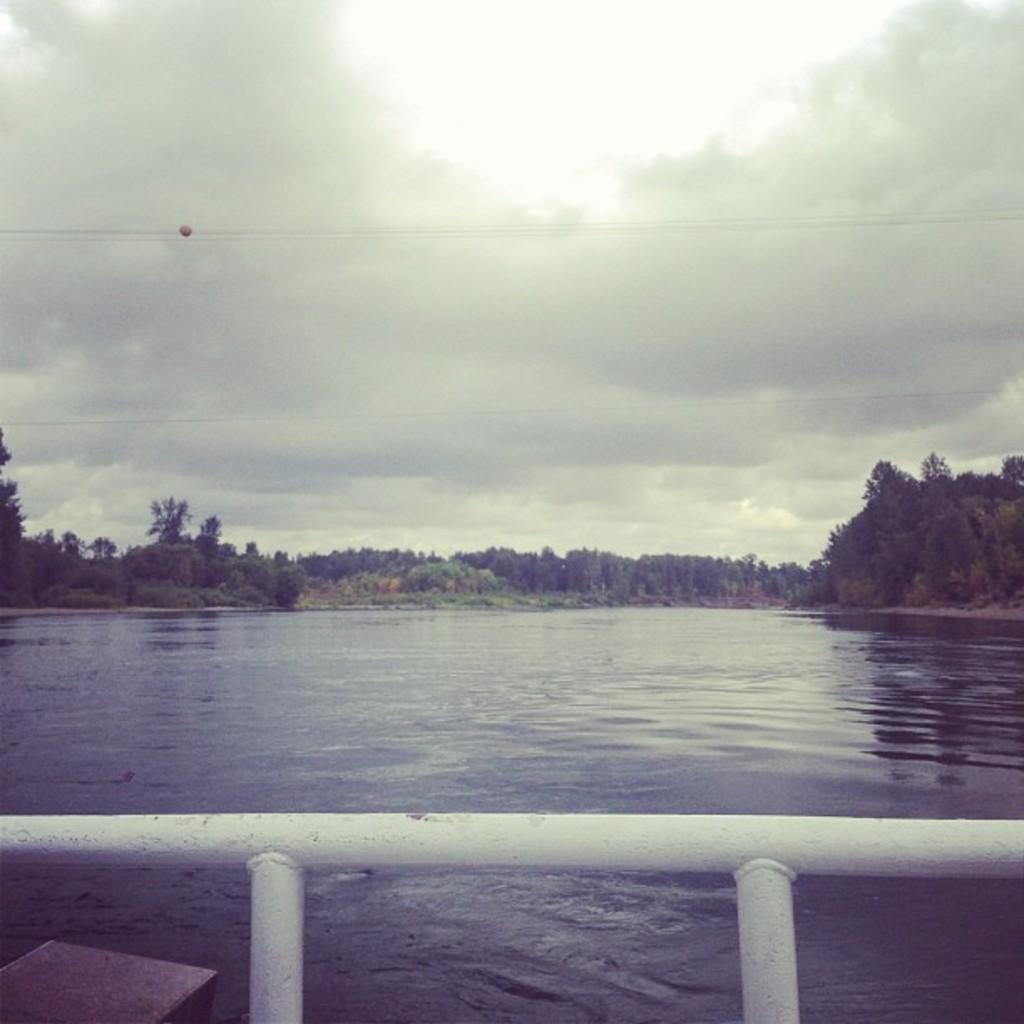How would you summarize this image in a sentence or two? At the bottom we can see fence made of metal and there is an object on the water. In the background we can see water, trees on the ground and clouds in the sky. On the left side there is an object in the sky. 